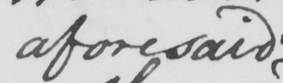Can you read and transcribe this handwriting? aforesaid 